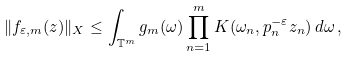Convert formula to latex. <formula><loc_0><loc_0><loc_500><loc_500>\| f _ { \varepsilon , m } ( z ) \| _ { X } \leq \int _ { \mathbb { T } ^ { m } } { g _ { m } ( \omega ) \prod _ { n = 1 } ^ { m } { K ( \omega _ { n } , p _ { n } ^ { - \varepsilon } z _ { n } ) } \, d \omega } \, ,</formula> 